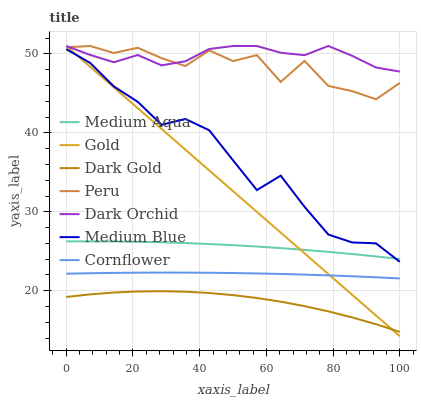Does Dark Gold have the minimum area under the curve?
Answer yes or no. Yes. Does Dark Orchid have the maximum area under the curve?
Answer yes or no. Yes. Does Gold have the minimum area under the curve?
Answer yes or no. No. Does Gold have the maximum area under the curve?
Answer yes or no. No. Is Gold the smoothest?
Answer yes or no. Yes. Is Peru the roughest?
Answer yes or no. Yes. Is Dark Gold the smoothest?
Answer yes or no. No. Is Dark Gold the roughest?
Answer yes or no. No. Does Gold have the lowest value?
Answer yes or no. Yes. Does Dark Gold have the lowest value?
Answer yes or no. No. Does Peru have the highest value?
Answer yes or no. Yes. Does Dark Gold have the highest value?
Answer yes or no. No. Is Medium Blue less than Peru?
Answer yes or no. Yes. Is Dark Orchid greater than Medium Aqua?
Answer yes or no. Yes. Does Medium Blue intersect Gold?
Answer yes or no. Yes. Is Medium Blue less than Gold?
Answer yes or no. No. Is Medium Blue greater than Gold?
Answer yes or no. No. Does Medium Blue intersect Peru?
Answer yes or no. No. 